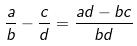Convert formula to latex. <formula><loc_0><loc_0><loc_500><loc_500>\frac { a } { b } - \frac { c } { d } = \frac { a d - b c } { b d }</formula> 